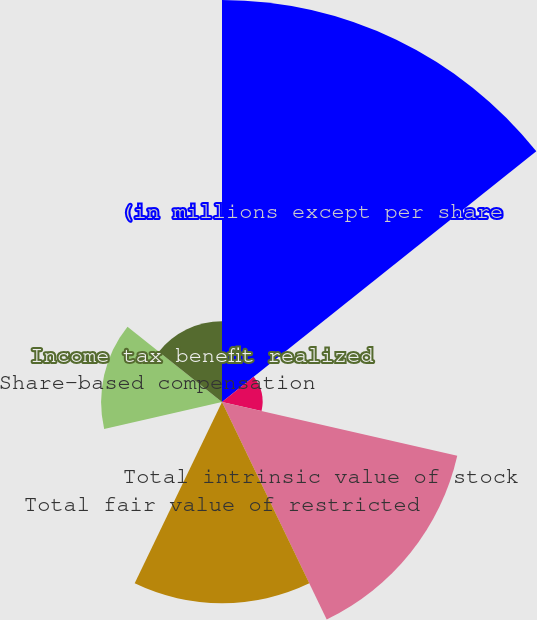Convert chart to OTSL. <chart><loc_0><loc_0><loc_500><loc_500><pie_chart><fcel>(in millions except per share<fcel>Weighted-average grant date<fcel>Total intrinsic value of stock<fcel>Total fair value of restricted<fcel>Number of shares purchased<fcel>Share-based compensation<fcel>Income tax benefit realized<nl><fcel>36.98%<fcel>3.73%<fcel>22.2%<fcel>18.51%<fcel>0.04%<fcel>11.12%<fcel>7.43%<nl></chart> 